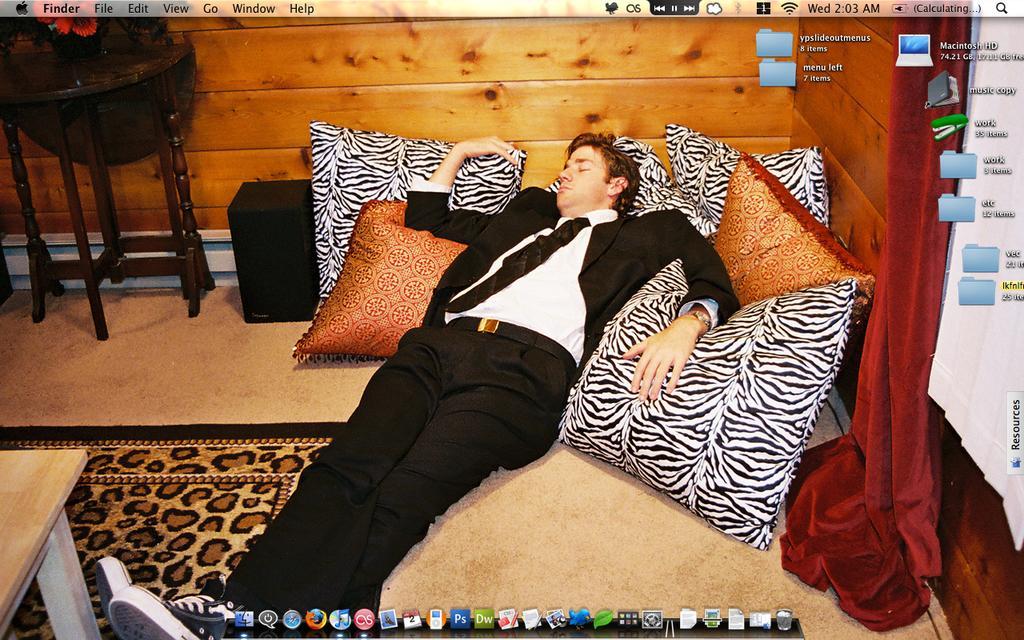How would you summarize this image in a sentence or two? This is a picture of a man in black blazer lying on a floor. On floor there are pillows, mat and tables. This is looking like a screen wallpaper. 